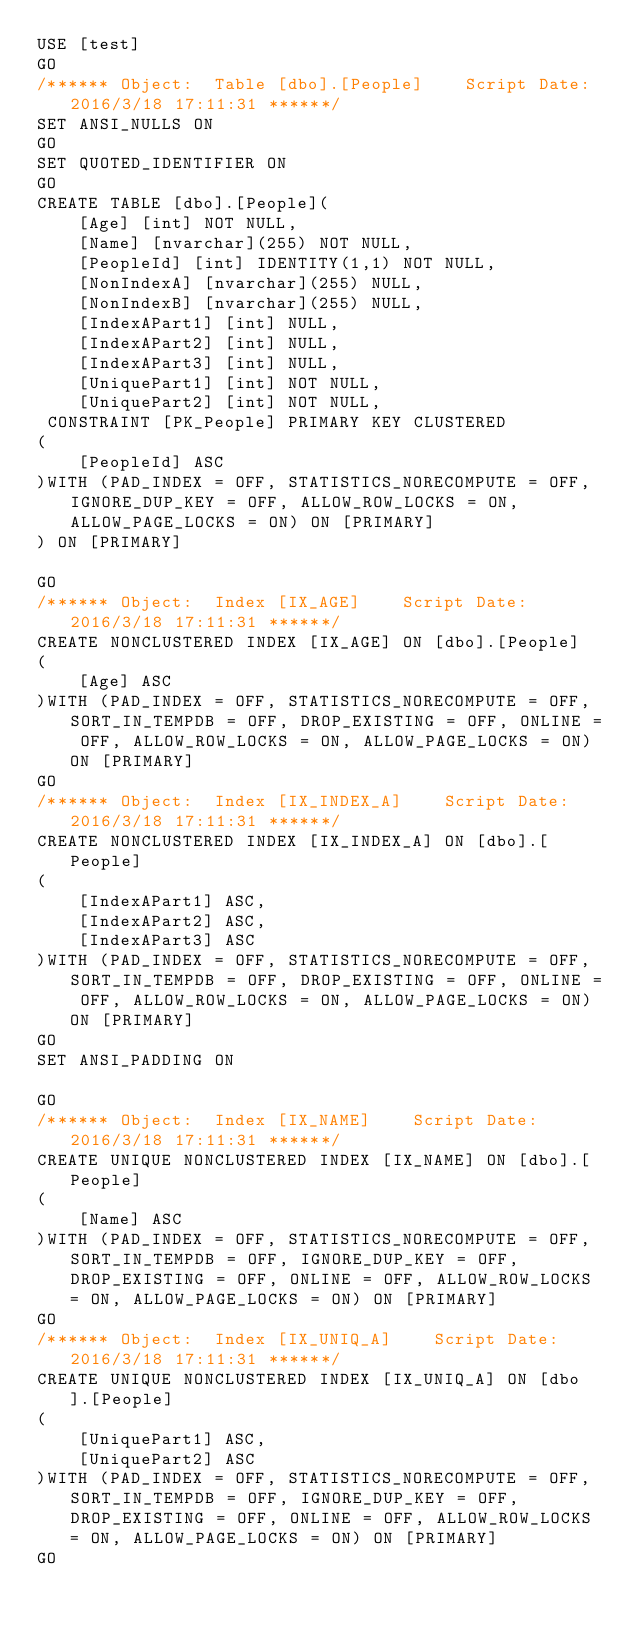Convert code to text. <code><loc_0><loc_0><loc_500><loc_500><_SQL_>USE [test]
GO
/****** Object:  Table [dbo].[People]    Script Date: 2016/3/18 17:11:31 ******/
SET ANSI_NULLS ON
GO
SET QUOTED_IDENTIFIER ON
GO
CREATE TABLE [dbo].[People](
	[Age] [int] NOT NULL,
	[Name] [nvarchar](255) NOT NULL,
	[PeopleId] [int] IDENTITY(1,1) NOT NULL,
	[NonIndexA] [nvarchar](255) NULL,
	[NonIndexB] [nvarchar](255) NULL,
	[IndexAPart1] [int] NULL,
	[IndexAPart2] [int] NULL,
	[IndexAPart3] [int] NULL,
	[UniquePart1] [int] NOT NULL,
	[UniquePart2] [int] NOT NULL,
 CONSTRAINT [PK_People] PRIMARY KEY CLUSTERED
(
	[PeopleId] ASC
)WITH (PAD_INDEX = OFF, STATISTICS_NORECOMPUTE = OFF, IGNORE_DUP_KEY = OFF, ALLOW_ROW_LOCKS = ON, ALLOW_PAGE_LOCKS = ON) ON [PRIMARY]
) ON [PRIMARY]

GO
/****** Object:  Index [IX_AGE]    Script Date: 2016/3/18 17:11:31 ******/
CREATE NONCLUSTERED INDEX [IX_AGE] ON [dbo].[People]
(
	[Age] ASC
)WITH (PAD_INDEX = OFF, STATISTICS_NORECOMPUTE = OFF, SORT_IN_TEMPDB = OFF, DROP_EXISTING = OFF, ONLINE = OFF, ALLOW_ROW_LOCKS = ON, ALLOW_PAGE_LOCKS = ON) ON [PRIMARY]
GO
/****** Object:  Index [IX_INDEX_A]    Script Date: 2016/3/18 17:11:31 ******/
CREATE NONCLUSTERED INDEX [IX_INDEX_A] ON [dbo].[People]
(
	[IndexAPart1] ASC,
	[IndexAPart2] ASC,
	[IndexAPart3] ASC
)WITH (PAD_INDEX = OFF, STATISTICS_NORECOMPUTE = OFF, SORT_IN_TEMPDB = OFF, DROP_EXISTING = OFF, ONLINE = OFF, ALLOW_ROW_LOCKS = ON, ALLOW_PAGE_LOCKS = ON) ON [PRIMARY]
GO
SET ANSI_PADDING ON

GO
/****** Object:  Index [IX_NAME]    Script Date: 2016/3/18 17:11:31 ******/
CREATE UNIQUE NONCLUSTERED INDEX [IX_NAME] ON [dbo].[People]
(
	[Name] ASC
)WITH (PAD_INDEX = OFF, STATISTICS_NORECOMPUTE = OFF, SORT_IN_TEMPDB = OFF, IGNORE_DUP_KEY = OFF, DROP_EXISTING = OFF, ONLINE = OFF, ALLOW_ROW_LOCKS = ON, ALLOW_PAGE_LOCKS = ON) ON [PRIMARY]
GO
/****** Object:  Index [IX_UNIQ_A]    Script Date: 2016/3/18 17:11:31 ******/
CREATE UNIQUE NONCLUSTERED INDEX [IX_UNIQ_A] ON [dbo].[People]
(
	[UniquePart1] ASC,
	[UniquePart2] ASC
)WITH (PAD_INDEX = OFF, STATISTICS_NORECOMPUTE = OFF, SORT_IN_TEMPDB = OFF, IGNORE_DUP_KEY = OFF, DROP_EXISTING = OFF, ONLINE = OFF, ALLOW_ROW_LOCKS = ON, ALLOW_PAGE_LOCKS = ON) ON [PRIMARY]
GO
</code> 